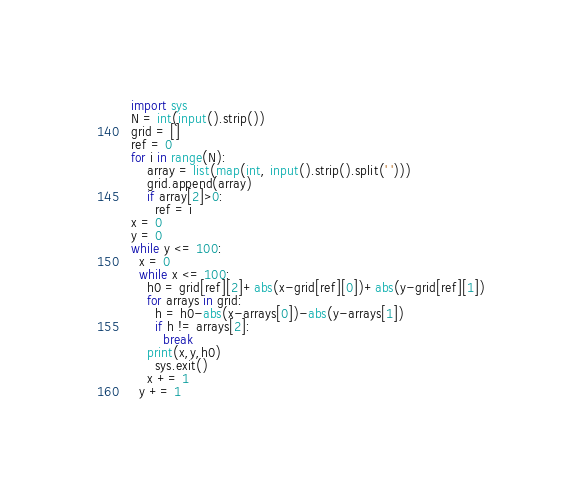Convert code to text. <code><loc_0><loc_0><loc_500><loc_500><_Python_>import sys
N = int(input().strip())
grid = []
ref = 0
for i in range(N):
    array = list(map(int, input().strip().split(' ')))
    grid.append(array)
    if array[2]>0:
      ref = i
x = 0
y = 0
while y <= 100:
  x = 0
  while x <= 100:
    h0 = grid[ref][2]+abs(x-grid[ref][0])+abs(y-grid[ref][1])
    for arrays in grid:
      h = h0-abs(x-arrays[0])-abs(y-arrays[1])
      if h != arrays[2]:
        break
    print(x,y,h0)
      sys.exit()
    x += 1
  y += 1</code> 